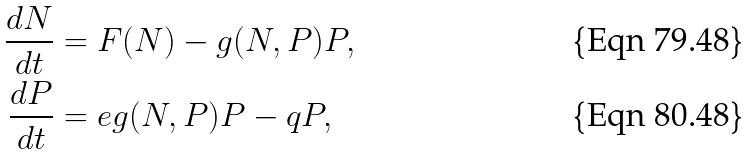Convert formula to latex. <formula><loc_0><loc_0><loc_500><loc_500>\frac { d N } { d t } & = F ( N ) - g ( N , P ) P , \\ \frac { d P } { d t } & = e g ( N , P ) P - q P ,</formula> 